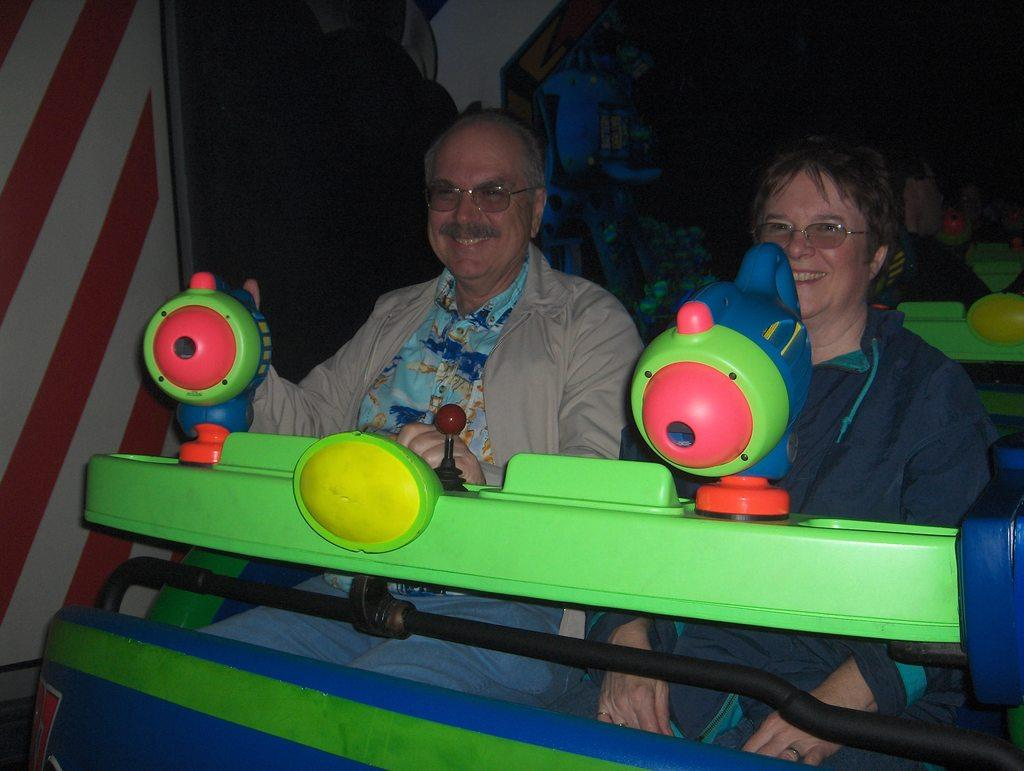How many people are present in the image? There are two people sitting in the image. What are the people wearing? The people are wearing different color dresses. What can be seen in the image besides the people? There is a multi-color ride in the image. What is the color of the background in the image? The background of the image is dark. What type of creature can be seen jumping over a clover in the image? There is no creature or clover present in the image; it features two people sitting and a multi-color ride. 